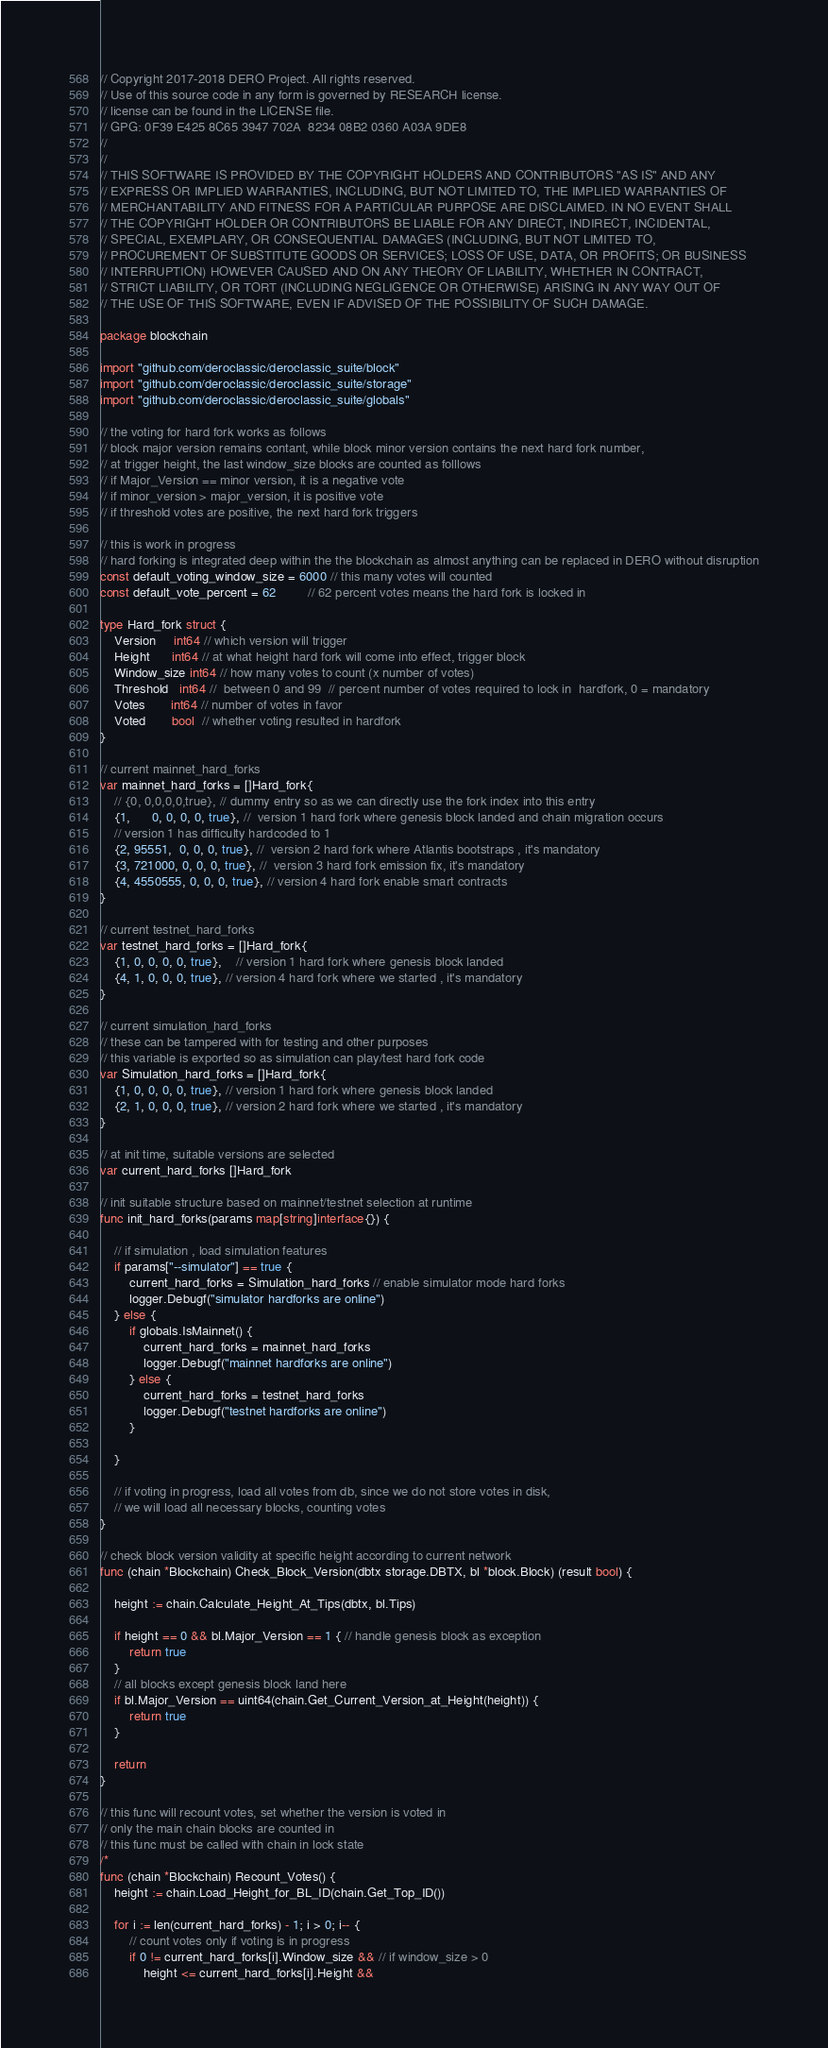<code> <loc_0><loc_0><loc_500><loc_500><_Go_>// Copyright 2017-2018 DERO Project. All rights reserved.
// Use of this source code in any form is governed by RESEARCH license.
// license can be found in the LICENSE file.
// GPG: 0F39 E425 8C65 3947 702A  8234 08B2 0360 A03A 9DE8
//
//
// THIS SOFTWARE IS PROVIDED BY THE COPYRIGHT HOLDERS AND CONTRIBUTORS "AS IS" AND ANY
// EXPRESS OR IMPLIED WARRANTIES, INCLUDING, BUT NOT LIMITED TO, THE IMPLIED WARRANTIES OF
// MERCHANTABILITY AND FITNESS FOR A PARTICULAR PURPOSE ARE DISCLAIMED. IN NO EVENT SHALL
// THE COPYRIGHT HOLDER OR CONTRIBUTORS BE LIABLE FOR ANY DIRECT, INDIRECT, INCIDENTAL,
// SPECIAL, EXEMPLARY, OR CONSEQUENTIAL DAMAGES (INCLUDING, BUT NOT LIMITED TO,
// PROCUREMENT OF SUBSTITUTE GOODS OR SERVICES; LOSS OF USE, DATA, OR PROFITS; OR BUSINESS
// INTERRUPTION) HOWEVER CAUSED AND ON ANY THEORY OF LIABILITY, WHETHER IN CONTRACT,
// STRICT LIABILITY, OR TORT (INCLUDING NEGLIGENCE OR OTHERWISE) ARISING IN ANY WAY OUT OF
// THE USE OF THIS SOFTWARE, EVEN IF ADVISED OF THE POSSIBILITY OF SUCH DAMAGE.

package blockchain

import "github.com/deroclassic/deroclassic_suite/block"
import "github.com/deroclassic/deroclassic_suite/storage"
import "github.com/deroclassic/deroclassic_suite/globals"

// the voting for hard fork works as follows
// block major version remains contant, while block minor version contains the next hard fork number,
// at trigger height, the last window_size blocks are counted as folllows
// if Major_Version == minor version, it is a negative vote
// if minor_version > major_version, it is positive vote
// if threshold votes are positive, the next hard fork triggers

// this is work in progress
// hard forking is integrated deep within the the blockchain as almost anything can be replaced in DERO without disruption
const default_voting_window_size = 6000 // this many votes will counted
const default_vote_percent = 62         // 62 percent votes means the hard fork is locked in

type Hard_fork struct {
	Version     int64 // which version will trigger
	Height      int64 // at what height hard fork will come into effect, trigger block
	Window_size int64 // how many votes to count (x number of votes)
	Threshold   int64 //  between 0 and 99  // percent number of votes required to lock in  hardfork, 0 = mandatory
	Votes       int64 // number of votes in favor
	Voted       bool  // whether voting resulted in hardfork
}

// current mainnet_hard_forks
var mainnet_hard_forks = []Hard_fork{
	// {0, 0,0,0,0,true}, // dummy entry so as we can directly use the fork index into this entry
	{1,      0, 0, 0, 0, true}, //  version 1 hard fork where genesis block landed and chain migration occurs
	// version 1 has difficulty hardcoded to 1
	{2, 95551,  0, 0, 0, true}, //  version 2 hard fork where Atlantis bootstraps , it's mandatory
	{3, 721000, 0, 0, 0, true}, //  version 3 hard fork emission fix, it's mandatory
	{4, 4550555, 0, 0, 0, true}, // version 4 hard fork enable smart contracts
}

// current testnet_hard_forks
var testnet_hard_forks = []Hard_fork{
	{1, 0, 0, 0, 0, true},    // version 1 hard fork where genesis block landed
	{4, 1, 0, 0, 0, true}, // version 4 hard fork where we started , it's mandatory
}

// current simulation_hard_forks
// these can be tampered with for testing and other purposes
// this variable is exported so as simulation can play/test hard fork code
var Simulation_hard_forks = []Hard_fork{
	{1, 0, 0, 0, 0, true}, // version 1 hard fork where genesis block landed
	{2, 1, 0, 0, 0, true}, // version 2 hard fork where we started , it's mandatory
}

// at init time, suitable versions are selected
var current_hard_forks []Hard_fork

// init suitable structure based on mainnet/testnet selection at runtime
func init_hard_forks(params map[string]interface{}) {

	// if simulation , load simulation features
	if params["--simulator"] == true {
		current_hard_forks = Simulation_hard_forks // enable simulator mode hard forks
		logger.Debugf("simulator hardforks are online")
	} else {
		if globals.IsMainnet() {
			current_hard_forks = mainnet_hard_forks
			logger.Debugf("mainnet hardforks are online")
		} else {
			current_hard_forks = testnet_hard_forks
			logger.Debugf("testnet hardforks are online")
		}

	}

	// if voting in progress, load all votes from db, since we do not store votes in disk,
	// we will load all necessary blocks, counting votes
}

// check block version validity at specific height according to current network
func (chain *Blockchain) Check_Block_Version(dbtx storage.DBTX, bl *block.Block) (result bool) {

	height := chain.Calculate_Height_At_Tips(dbtx, bl.Tips)

	if height == 0 && bl.Major_Version == 1 { // handle genesis block as exception
		return true
	}
	// all blocks except genesis block land here
	if bl.Major_Version == uint64(chain.Get_Current_Version_at_Height(height)) {
		return true
	}

	return
}

// this func will recount votes, set whether the version is voted in
// only the main chain blocks are counted in
// this func must be called with chain in lock state
/*
func (chain *Blockchain) Recount_Votes() {
	height := chain.Load_Height_for_BL_ID(chain.Get_Top_ID())

	for i := len(current_hard_forks) - 1; i > 0; i-- {
		// count votes only if voting is in progress
		if 0 != current_hard_forks[i].Window_size && // if window_size > 0
			height <= current_hard_forks[i].Height &&</code> 